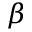<formula> <loc_0><loc_0><loc_500><loc_500>\beta</formula> 